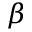<formula> <loc_0><loc_0><loc_500><loc_500>\beta</formula> 